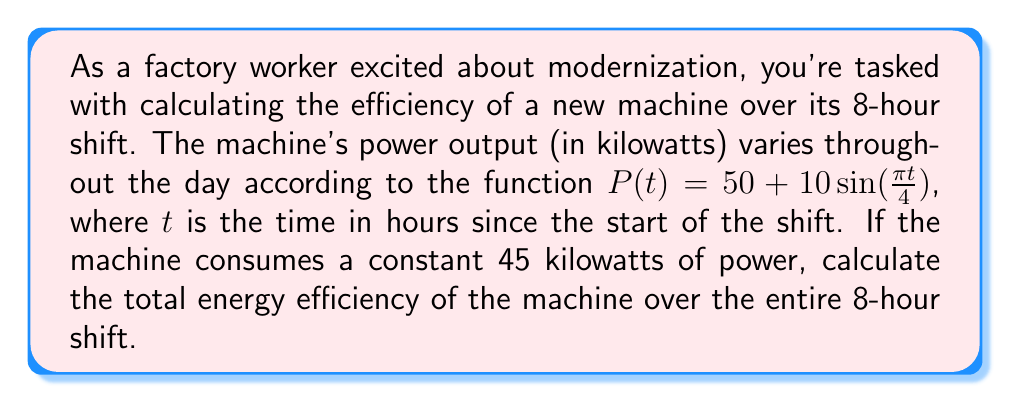Can you solve this math problem? To solve this problem, we need to follow these steps:

1) First, we need to calculate the total energy output of the machine over the 8-hour shift. This can be done by integrating the power function over time:

   $$E_{out} = \int_0^8 P(t) dt = \int_0^8 (50 + 10\sin(\frac{\pi t}{4})) dt$$

2) Let's solve this integral:
   
   $$E_{out} = [50t - \frac{40}{\pi}\cos(\frac{\pi t}{4})]_0^8$$
   
   $$= (400 - \frac{40}{\pi}\cos(2\pi)) - (0 - \frac{40}{\pi}\cos(0))$$
   
   $$= 400 - \frac{40}{\pi}\cos(2\pi) + \frac{40}{\pi}$$
   
   $$= 400 + \frac{40}{\pi}(1 - \cos(2\pi)) = 400$$ kilowatt-hours

3) Now, let's calculate the total energy input. The machine consumes a constant 45 kilowatts over 8 hours:

   $$E_{in} = 45 * 8 = 360$$ kilowatt-hours

4) The efficiency is the ratio of output energy to input energy:

   $$Efficiency = \frac{E_{out}}{E_{in}} = \frac{400}{360} \approx 1.1111$$

5) To express this as a percentage, we multiply by 100:

   $$Efficiency \approx 111.11\%$$
Answer: The total energy efficiency of the machine over the 8-hour shift is approximately 111.11%. 